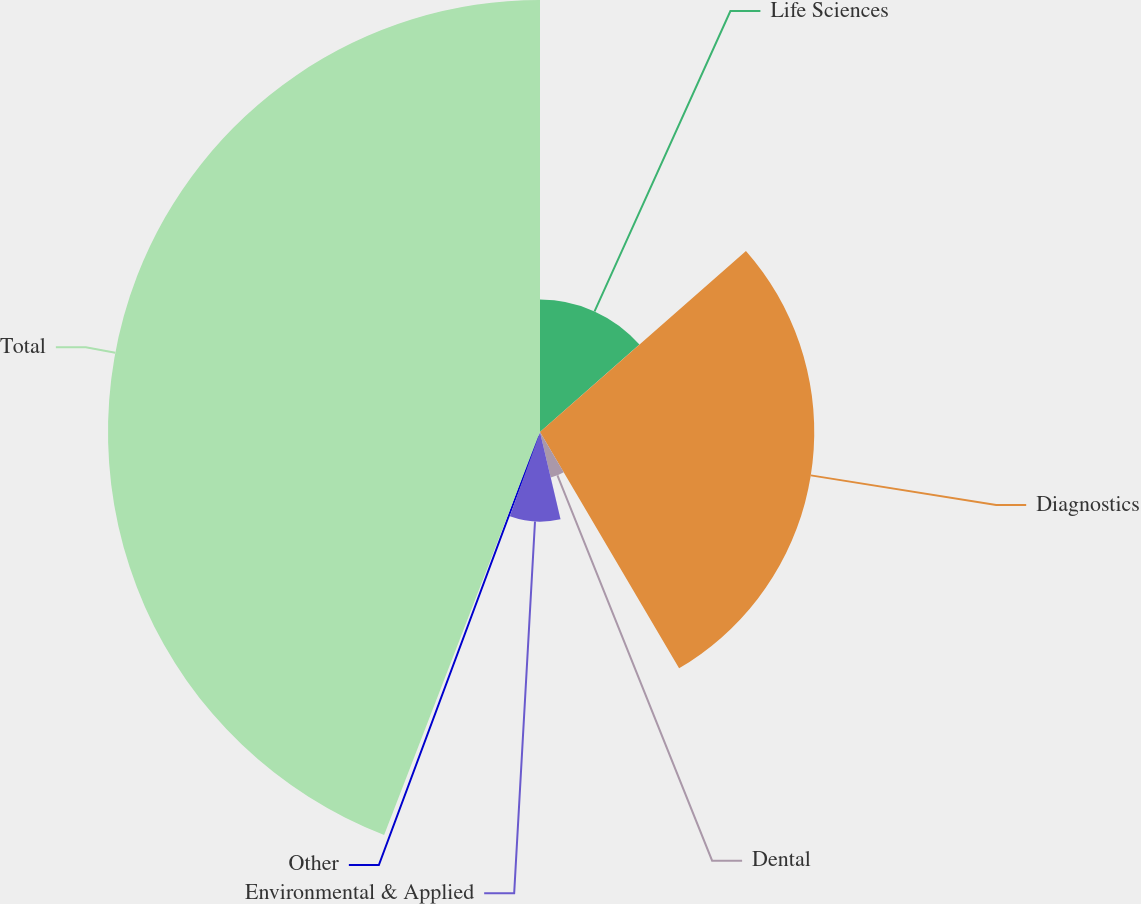Convert chart. <chart><loc_0><loc_0><loc_500><loc_500><pie_chart><fcel>Life Sciences<fcel>Diagnostics<fcel>Dental<fcel>Environmental & Applied<fcel>Other<fcel>Total<nl><fcel>13.52%<fcel>28.01%<fcel>4.78%<fcel>9.15%<fcel>0.41%<fcel>44.12%<nl></chart> 